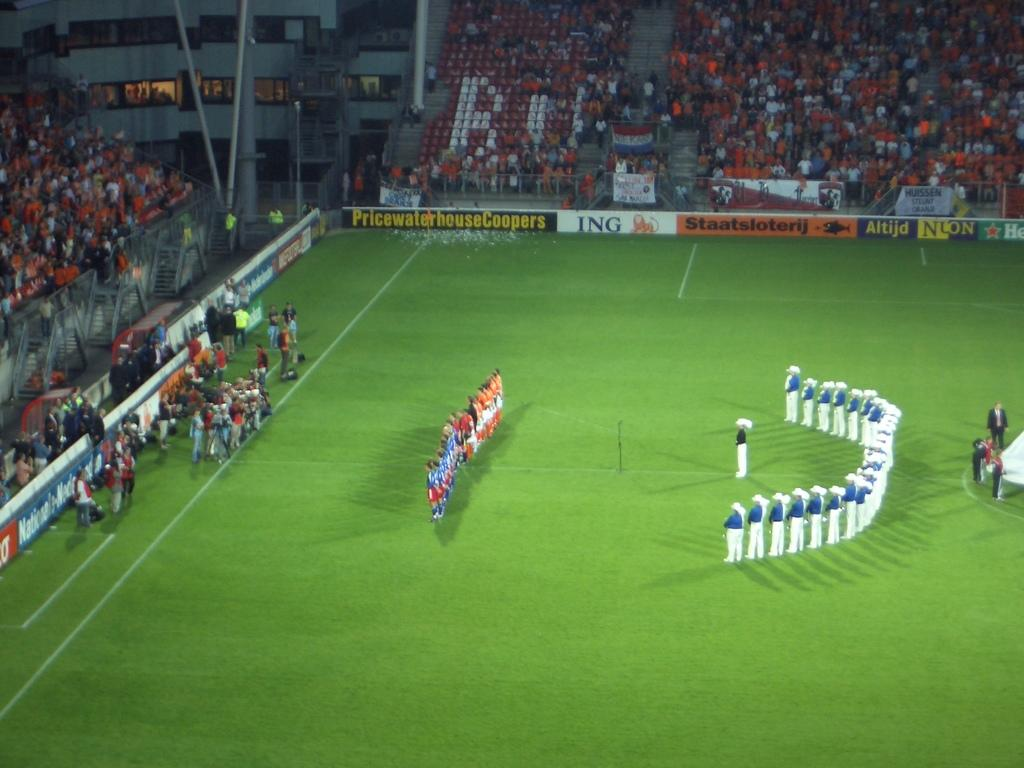<image>
Summarize the visual content of the image. Soccer players line up on a soccer field with a banner sponsored by PricewaterhouseCoopers. 